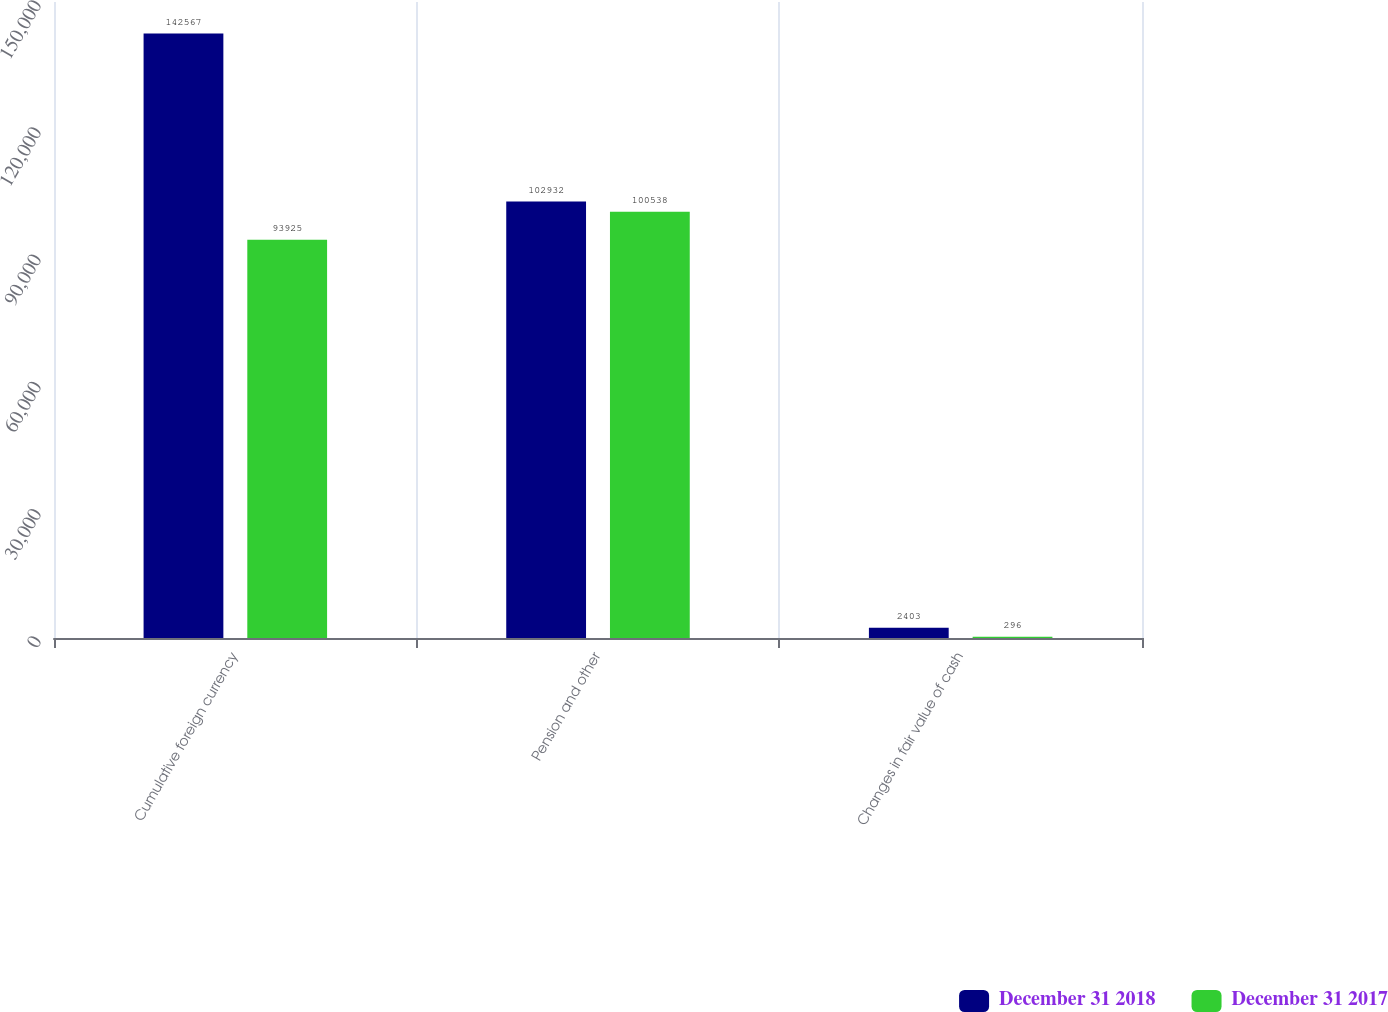Convert chart. <chart><loc_0><loc_0><loc_500><loc_500><stacked_bar_chart><ecel><fcel>Cumulative foreign currency<fcel>Pension and other<fcel>Changes in fair value of cash<nl><fcel>December 31 2018<fcel>142567<fcel>102932<fcel>2403<nl><fcel>December 31 2017<fcel>93925<fcel>100538<fcel>296<nl></chart> 